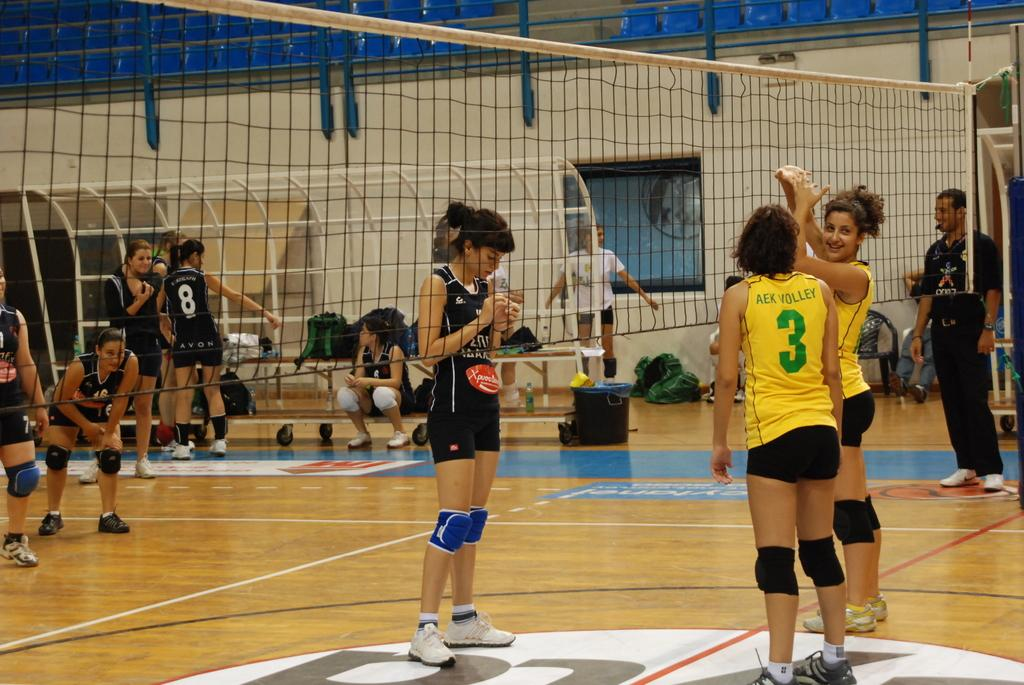How many people are in the image? There is a group of people standing in the image. What items can be seen in addition to the people? There are bags, a net, a bottle, benches, chairs, iron rods, a trolley, a dustbin, and a staircase in the image. What type of container is present for disposing of waste? There is a dustbin in the image. Can you describe the seating arrangements in the image? There are benches and chairs in the image. What type of pain can be seen on the faces of the people in the image? There is no indication of pain on the faces of the people in the image. Are there any jellyfish visible in the image? There are no jellyfish present in the image. 